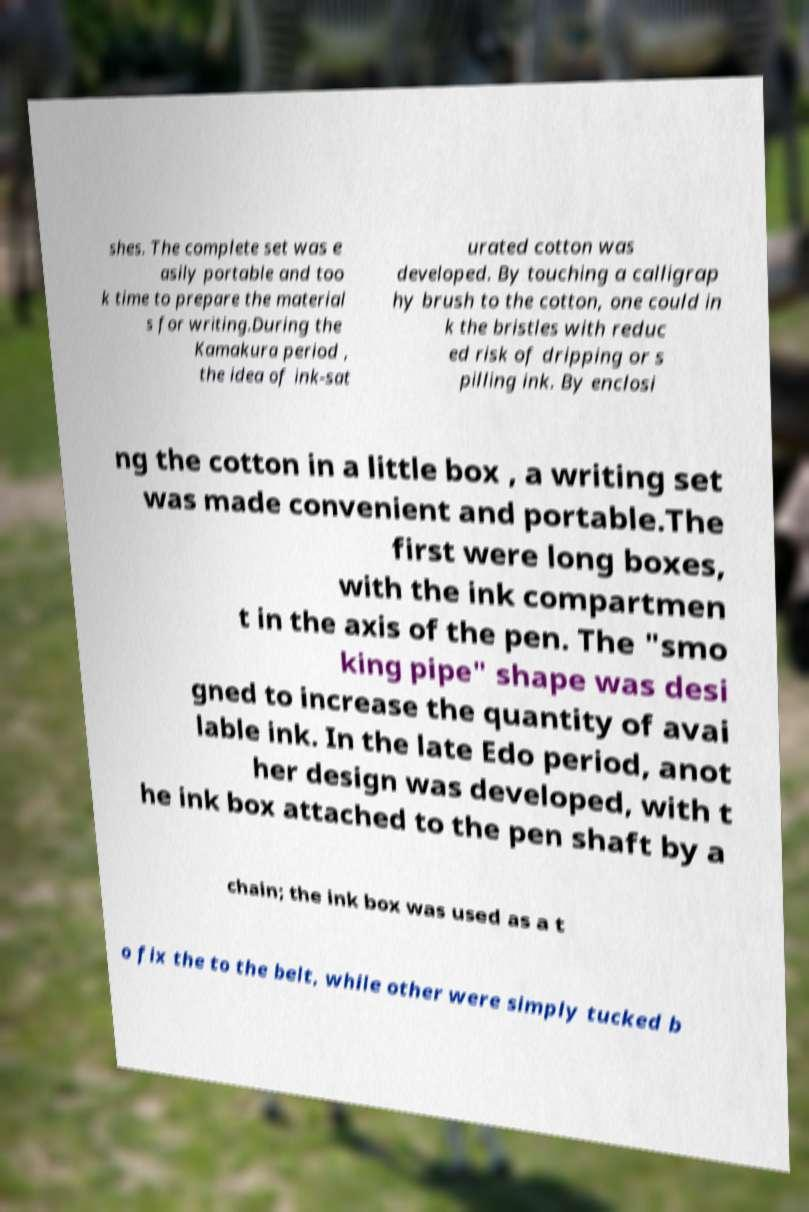I need the written content from this picture converted into text. Can you do that? shes. The complete set was e asily portable and too k time to prepare the material s for writing.During the Kamakura period , the idea of ink-sat urated cotton was developed. By touching a calligrap hy brush to the cotton, one could in k the bristles with reduc ed risk of dripping or s pilling ink. By enclosi ng the cotton in a little box , a writing set was made convenient and portable.The first were long boxes, with the ink compartmen t in the axis of the pen. The "smo king pipe" shape was desi gned to increase the quantity of avai lable ink. In the late Edo period, anot her design was developed, with t he ink box attached to the pen shaft by a chain; the ink box was used as a t o fix the to the belt, while other were simply tucked b 